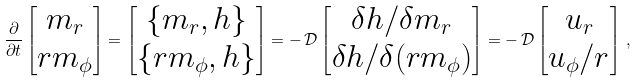<formula> <loc_0><loc_0><loc_500><loc_500>\frac { \partial } { \partial t } \begin{bmatrix} m _ { r } \\ r m _ { \phi } \end{bmatrix} = \begin{bmatrix} \{ m _ { r } , h \} \\ \{ r m _ { \phi } , h \} \end{bmatrix} = - \, \mathcal { D } \begin{bmatrix} { \delta h / \delta m _ { r } } \\ { \delta h / \delta ( r m _ { \phi } ) } \end{bmatrix} = - \, \mathcal { D } \begin{bmatrix} u _ { r } \\ u _ { \phi } / r \end{bmatrix} \, ,</formula> 